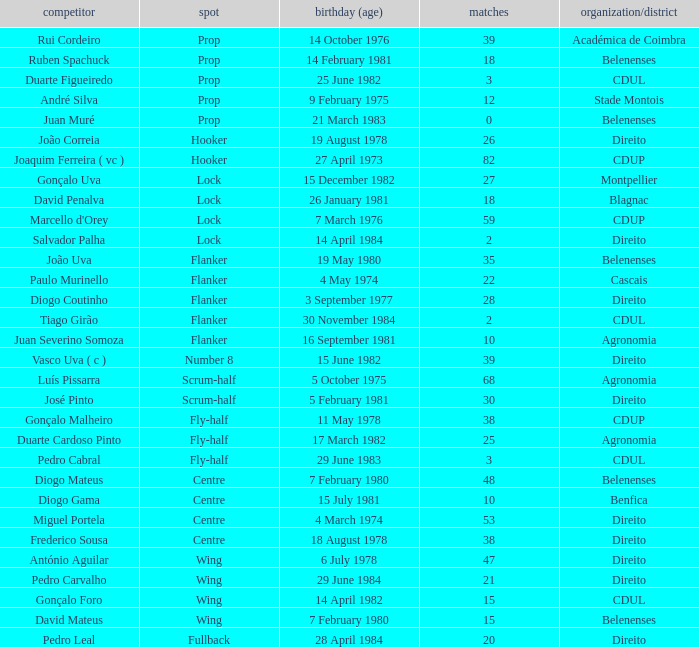Could you help me parse every detail presented in this table? {'header': ['competitor', 'spot', 'birthday (age)', 'matches', 'organization/district'], 'rows': [['Rui Cordeiro', 'Prop', '14 October 1976', '39', 'Académica de Coimbra'], ['Ruben Spachuck', 'Prop', '14 February 1981', '18', 'Belenenses'], ['Duarte Figueiredo', 'Prop', '25 June 1982', '3', 'CDUL'], ['André Silva', 'Prop', '9 February 1975', '12', 'Stade Montois'], ['Juan Muré', 'Prop', '21 March 1983', '0', 'Belenenses'], ['João Correia', 'Hooker', '19 August 1978', '26', 'Direito'], ['Joaquim Ferreira ( vc )', 'Hooker', '27 April 1973', '82', 'CDUP'], ['Gonçalo Uva', 'Lock', '15 December 1982', '27', 'Montpellier'], ['David Penalva', 'Lock', '26 January 1981', '18', 'Blagnac'], ["Marcello d'Orey", 'Lock', '7 March 1976', '59', 'CDUP'], ['Salvador Palha', 'Lock', '14 April 1984', '2', 'Direito'], ['João Uva', 'Flanker', '19 May 1980', '35', 'Belenenses'], ['Paulo Murinello', 'Flanker', '4 May 1974', '22', 'Cascais'], ['Diogo Coutinho', 'Flanker', '3 September 1977', '28', 'Direito'], ['Tiago Girão', 'Flanker', '30 November 1984', '2', 'CDUL'], ['Juan Severino Somoza', 'Flanker', '16 September 1981', '10', 'Agronomia'], ['Vasco Uva ( c )', 'Number 8', '15 June 1982', '39', 'Direito'], ['Luís Pissarra', 'Scrum-half', '5 October 1975', '68', 'Agronomia'], ['José Pinto', 'Scrum-half', '5 February 1981', '30', 'Direito'], ['Gonçalo Malheiro', 'Fly-half', '11 May 1978', '38', 'CDUP'], ['Duarte Cardoso Pinto', 'Fly-half', '17 March 1982', '25', 'Agronomia'], ['Pedro Cabral', 'Fly-half', '29 June 1983', '3', 'CDUL'], ['Diogo Mateus', 'Centre', '7 February 1980', '48', 'Belenenses'], ['Diogo Gama', 'Centre', '15 July 1981', '10', 'Benfica'], ['Miguel Portela', 'Centre', '4 March 1974', '53', 'Direito'], ['Frederico Sousa', 'Centre', '18 August 1978', '38', 'Direito'], ['António Aguilar', 'Wing', '6 July 1978', '47', 'Direito'], ['Pedro Carvalho', 'Wing', '29 June 1984', '21', 'Direito'], ['Gonçalo Foro', 'Wing', '14 April 1982', '15', 'CDUL'], ['David Mateus', 'Wing', '7 February 1980', '15', 'Belenenses'], ['Pedro Leal', 'Fullback', '28 April 1984', '20', 'Direito']]} Which player has a Club/province of direito, less than 21 caps, and a Position of lock? Salvador Palha. 